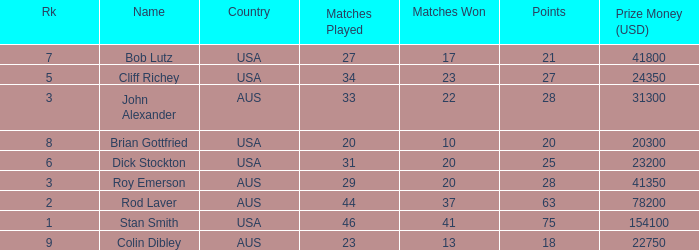How many matches did colin dibley win 13.0. 